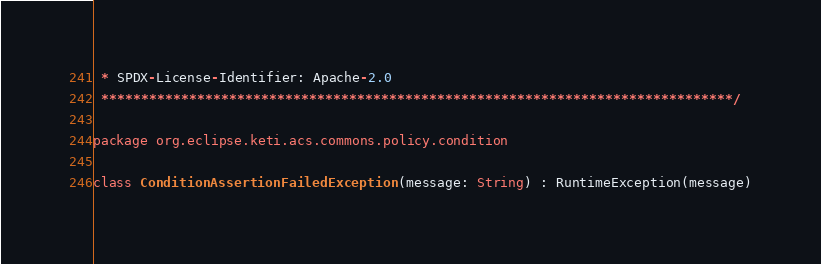<code> <loc_0><loc_0><loc_500><loc_500><_Kotlin_> * SPDX-License-Identifier: Apache-2.0
 *******************************************************************************/

package org.eclipse.keti.acs.commons.policy.condition

class ConditionAssertionFailedException(message: String) : RuntimeException(message)
</code> 